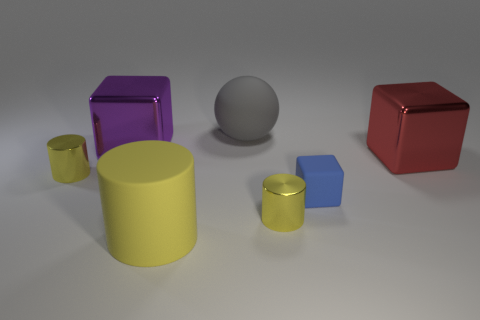There is a red block behind the yellow matte cylinder; does it have the same size as the big gray sphere?
Your answer should be compact. Yes. What is the shape of the red object that is the same size as the rubber ball?
Offer a very short reply. Cube. Is the shape of the big purple shiny thing the same as the blue thing?
Your response must be concise. Yes. What number of tiny yellow shiny things are the same shape as the big yellow thing?
Your answer should be compact. 2. There is a purple metal cube; what number of blue objects are behind it?
Make the answer very short. 0. Do the rubber object behind the big red thing and the tiny matte block have the same color?
Offer a very short reply. No. What number of blue rubber objects are the same size as the purple metal cube?
Provide a succinct answer. 0. What shape is the big yellow object that is the same material as the tiny blue object?
Provide a short and direct response. Cylinder. Is there a large matte thing that has the same color as the large cylinder?
Your answer should be compact. No. What is the large yellow thing made of?
Ensure brevity in your answer.  Rubber. 